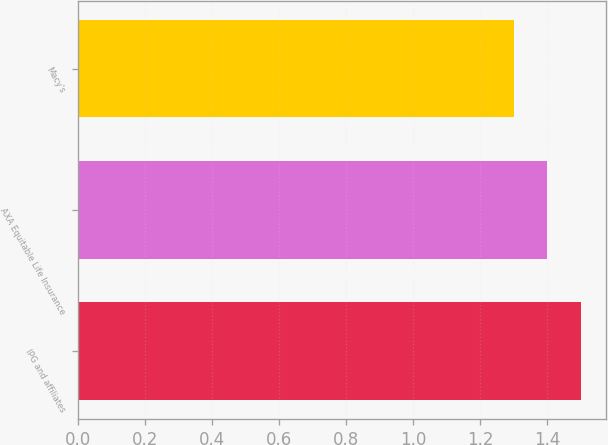Convert chart. <chart><loc_0><loc_0><loc_500><loc_500><bar_chart><fcel>IPG and affiliates<fcel>AXA Equitable Life Insurance<fcel>Macy's<nl><fcel>1.5<fcel>1.4<fcel>1.3<nl></chart> 